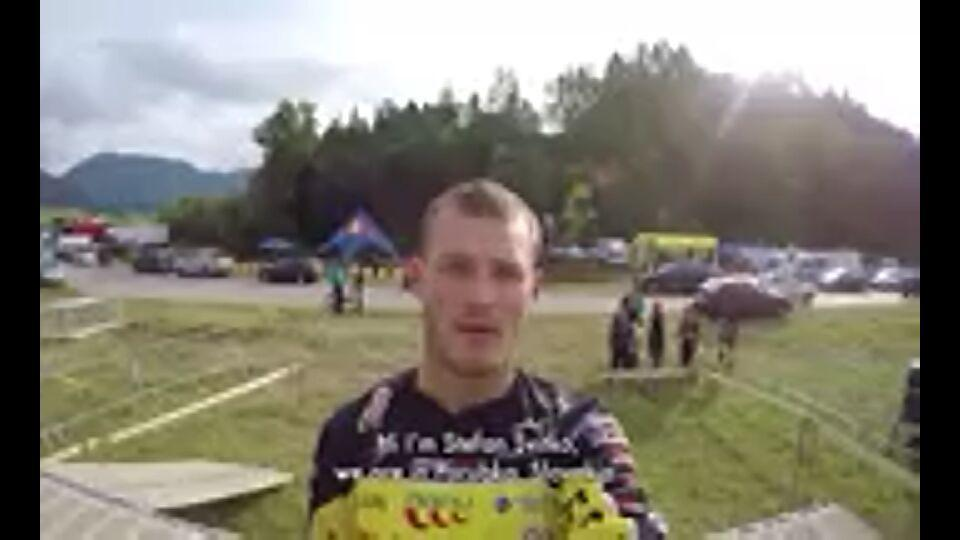What are the given signup options? The given signup options are "FACEBOOK", "GOOGLE" and "email". 